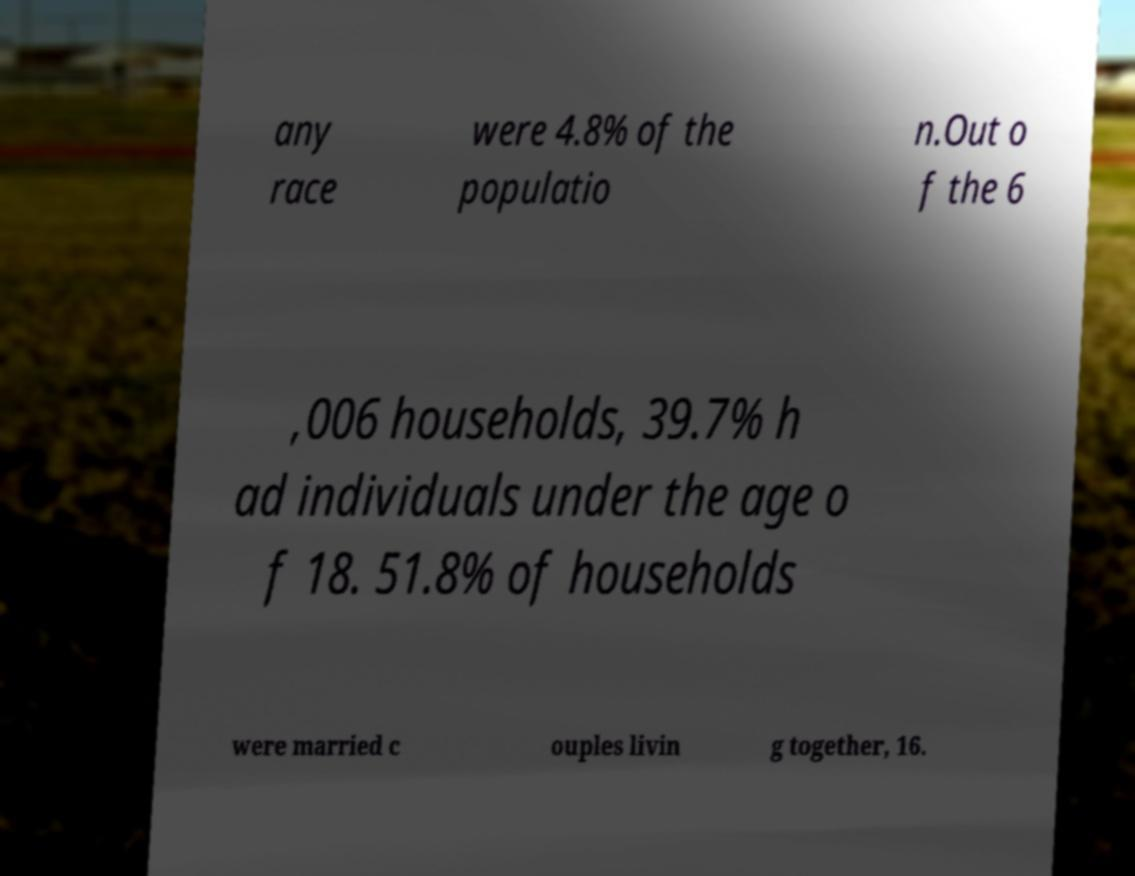Please read and relay the text visible in this image. What does it say? any race were 4.8% of the populatio n.Out o f the 6 ,006 households, 39.7% h ad individuals under the age o f 18. 51.8% of households were married c ouples livin g together, 16. 